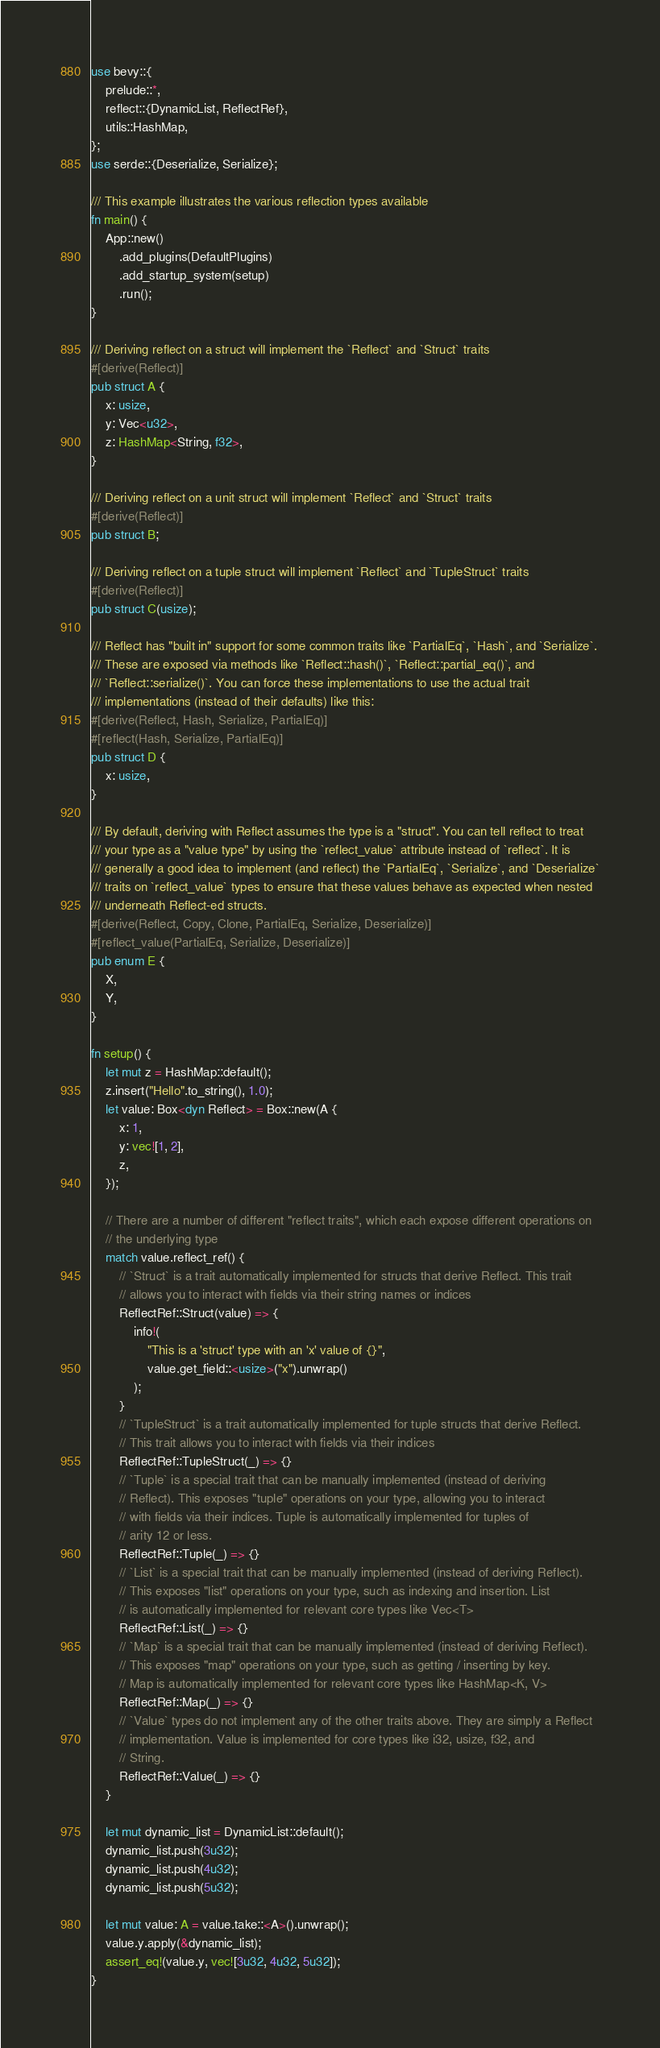Convert code to text. <code><loc_0><loc_0><loc_500><loc_500><_Rust_>use bevy::{
    prelude::*,
    reflect::{DynamicList, ReflectRef},
    utils::HashMap,
};
use serde::{Deserialize, Serialize};

/// This example illustrates the various reflection types available
fn main() {
    App::new()
        .add_plugins(DefaultPlugins)
        .add_startup_system(setup)
        .run();
}

/// Deriving reflect on a struct will implement the `Reflect` and `Struct` traits
#[derive(Reflect)]
pub struct A {
    x: usize,
    y: Vec<u32>,
    z: HashMap<String, f32>,
}

/// Deriving reflect on a unit struct will implement `Reflect` and `Struct` traits
#[derive(Reflect)]
pub struct B;

/// Deriving reflect on a tuple struct will implement `Reflect` and `TupleStruct` traits
#[derive(Reflect)]
pub struct C(usize);

/// Reflect has "built in" support for some common traits like `PartialEq`, `Hash`, and `Serialize`.
/// These are exposed via methods like `Reflect::hash()`, `Reflect::partial_eq()`, and
/// `Reflect::serialize()`. You can force these implementations to use the actual trait
/// implementations (instead of their defaults) like this:
#[derive(Reflect, Hash, Serialize, PartialEq)]
#[reflect(Hash, Serialize, PartialEq)]
pub struct D {
    x: usize,
}

/// By default, deriving with Reflect assumes the type is a "struct". You can tell reflect to treat
/// your type as a "value type" by using the `reflect_value` attribute instead of `reflect`. It is
/// generally a good idea to implement (and reflect) the `PartialEq`, `Serialize`, and `Deserialize`
/// traits on `reflect_value` types to ensure that these values behave as expected when nested
/// underneath Reflect-ed structs.
#[derive(Reflect, Copy, Clone, PartialEq, Serialize, Deserialize)]
#[reflect_value(PartialEq, Serialize, Deserialize)]
pub enum E {
    X,
    Y,
}

fn setup() {
    let mut z = HashMap::default();
    z.insert("Hello".to_string(), 1.0);
    let value: Box<dyn Reflect> = Box::new(A {
        x: 1,
        y: vec![1, 2],
        z,
    });

    // There are a number of different "reflect traits", which each expose different operations on
    // the underlying type
    match value.reflect_ref() {
        // `Struct` is a trait automatically implemented for structs that derive Reflect. This trait
        // allows you to interact with fields via their string names or indices
        ReflectRef::Struct(value) => {
            info!(
                "This is a 'struct' type with an 'x' value of {}",
                value.get_field::<usize>("x").unwrap()
            );
        }
        // `TupleStruct` is a trait automatically implemented for tuple structs that derive Reflect.
        // This trait allows you to interact with fields via their indices
        ReflectRef::TupleStruct(_) => {}
        // `Tuple` is a special trait that can be manually implemented (instead of deriving
        // Reflect). This exposes "tuple" operations on your type, allowing you to interact
        // with fields via their indices. Tuple is automatically implemented for tuples of
        // arity 12 or less.
        ReflectRef::Tuple(_) => {}
        // `List` is a special trait that can be manually implemented (instead of deriving Reflect).
        // This exposes "list" operations on your type, such as indexing and insertion. List
        // is automatically implemented for relevant core types like Vec<T>
        ReflectRef::List(_) => {}
        // `Map` is a special trait that can be manually implemented (instead of deriving Reflect).
        // This exposes "map" operations on your type, such as getting / inserting by key.
        // Map is automatically implemented for relevant core types like HashMap<K, V>
        ReflectRef::Map(_) => {}
        // `Value` types do not implement any of the other traits above. They are simply a Reflect
        // implementation. Value is implemented for core types like i32, usize, f32, and
        // String.
        ReflectRef::Value(_) => {}
    }

    let mut dynamic_list = DynamicList::default();
    dynamic_list.push(3u32);
    dynamic_list.push(4u32);
    dynamic_list.push(5u32);

    let mut value: A = value.take::<A>().unwrap();
    value.y.apply(&dynamic_list);
    assert_eq!(value.y, vec![3u32, 4u32, 5u32]);
}
</code> 